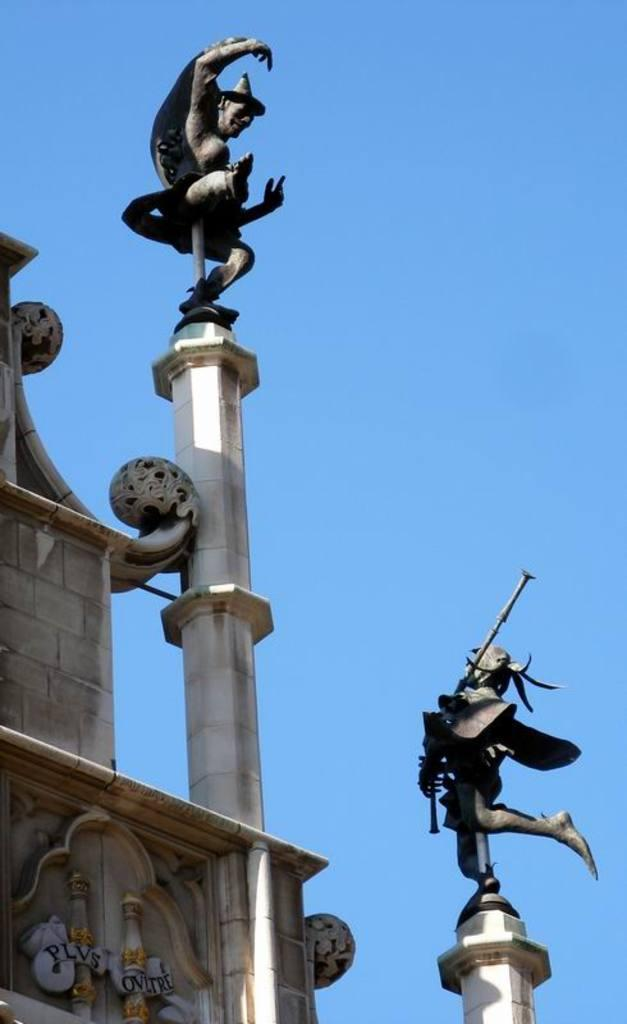What type of structure is visible in the image? There is a building in the image. What type of artwork can be seen in the image? Sculptures and statues are present in the image. What is located to the left of the image? There is a wall to the left of the image. What architectural feature is in the middle of the image? There is a pillar in the middle of the image. What can be seen in the background of the image? The sky is visible in the background of the image. What type of corn is growing on the pillar in the image? There is no corn present in the image; it features a building, sculptures and statues, a wall, a pillar, and the sky. 